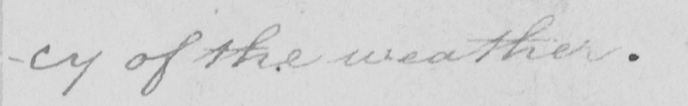Please transcribe the handwritten text in this image. -cy of the weather . 